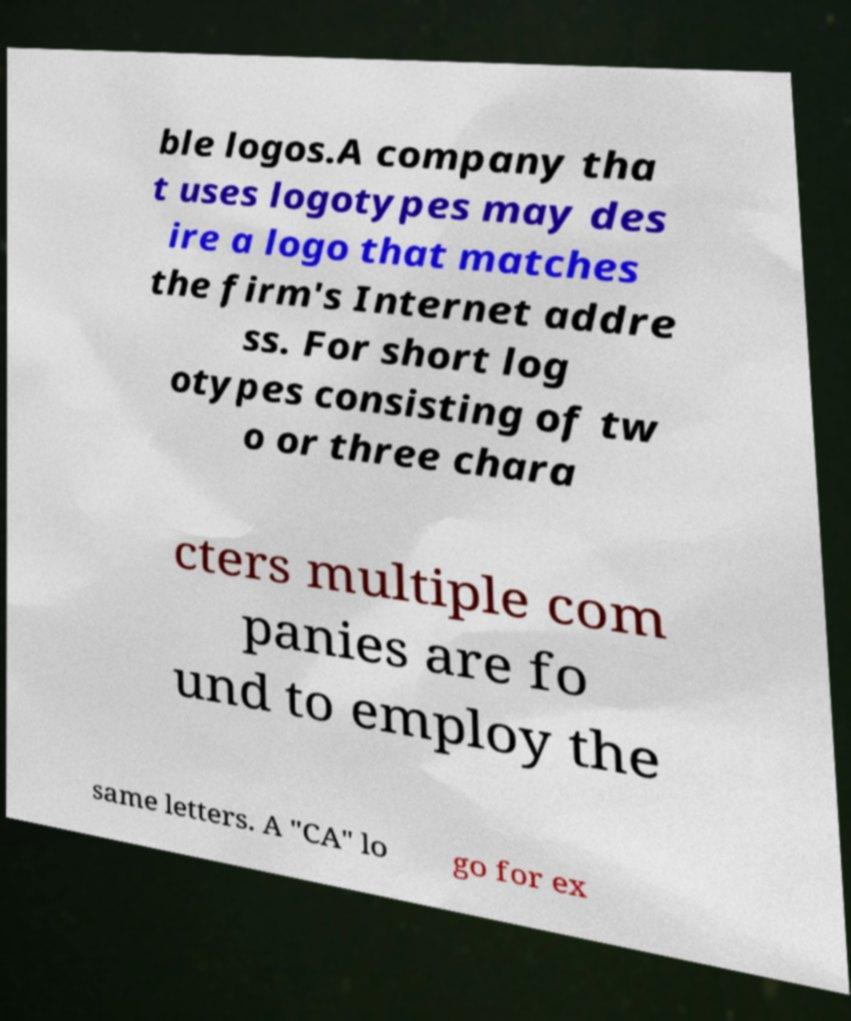Could you assist in decoding the text presented in this image and type it out clearly? ble logos.A company tha t uses logotypes may des ire a logo that matches the firm's Internet addre ss. For short log otypes consisting of tw o or three chara cters multiple com panies are fo und to employ the same letters. A "CA" lo go for ex 